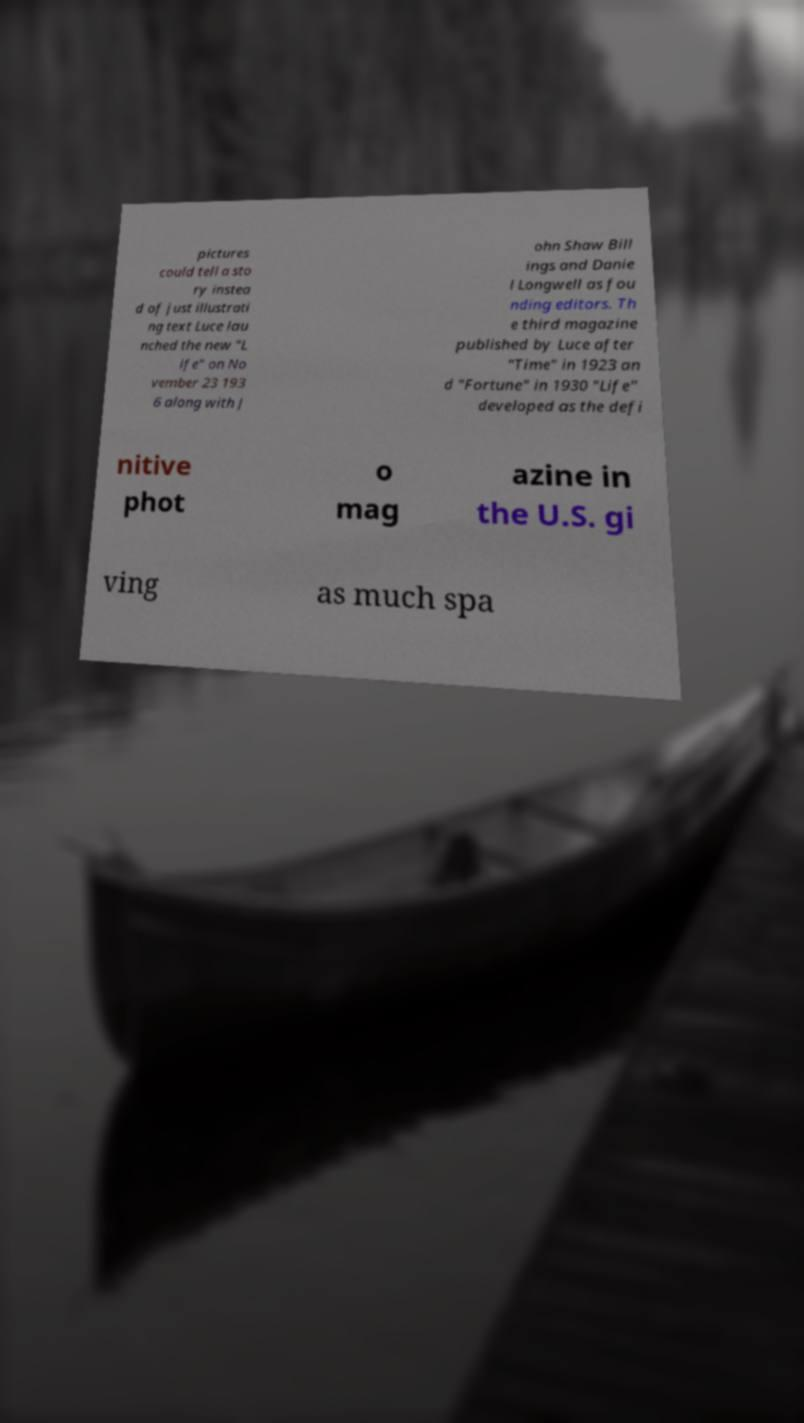I need the written content from this picture converted into text. Can you do that? pictures could tell a sto ry instea d of just illustrati ng text Luce lau nched the new "L ife" on No vember 23 193 6 along with J ohn Shaw Bill ings and Danie l Longwell as fou nding editors. Th e third magazine published by Luce after "Time" in 1923 an d "Fortune" in 1930 "Life" developed as the defi nitive phot o mag azine in the U.S. gi ving as much spa 